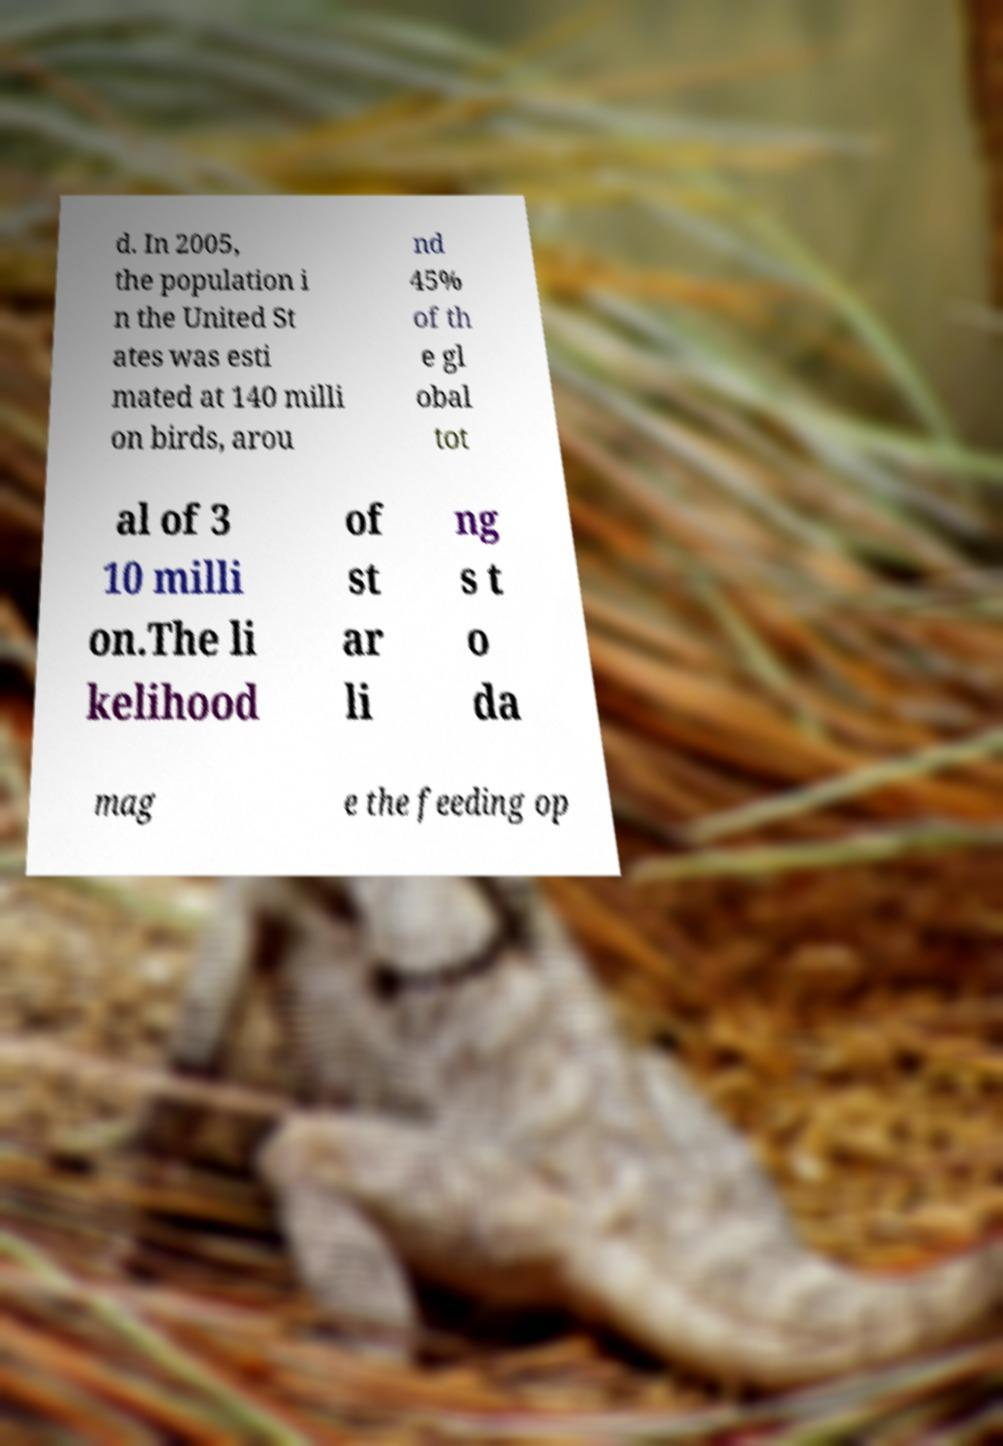There's text embedded in this image that I need extracted. Can you transcribe it verbatim? d. In 2005, the population i n the United St ates was esti mated at 140 milli on birds, arou nd 45% of th e gl obal tot al of 3 10 milli on.The li kelihood of st ar li ng s t o da mag e the feeding op 